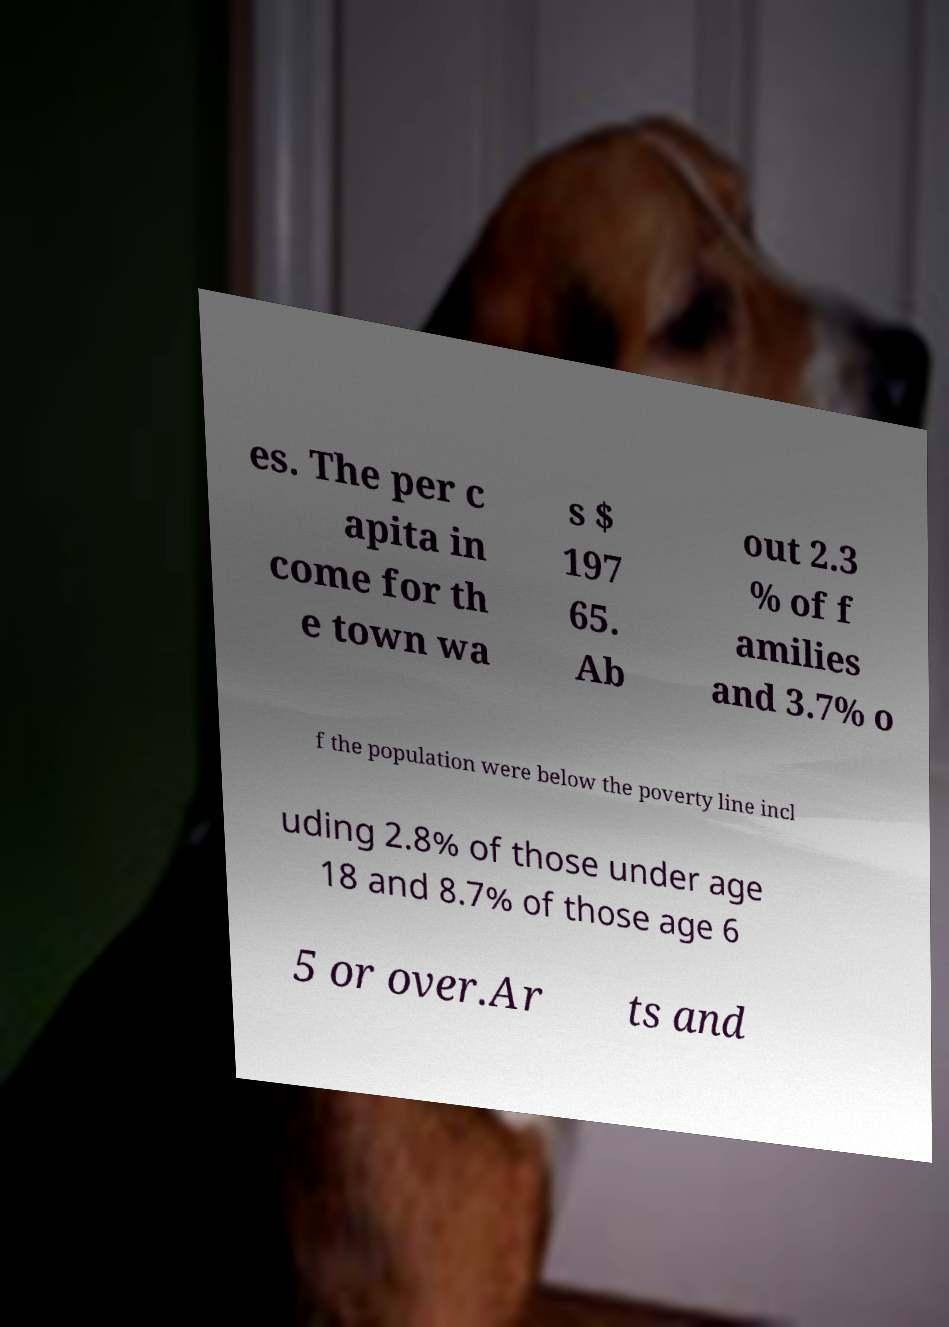Can you accurately transcribe the text from the provided image for me? es. The per c apita in come for th e town wa s $ 197 65. Ab out 2.3 % of f amilies and 3.7% o f the population were below the poverty line incl uding 2.8% of those under age 18 and 8.7% of those age 6 5 or over.Ar ts and 